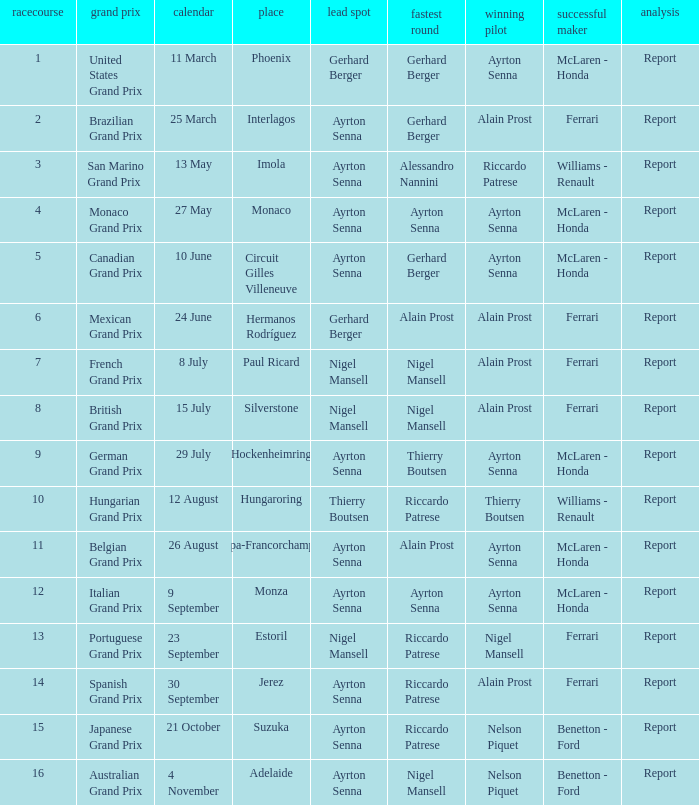Could you help me parse every detail presented in this table? {'header': ['racecourse', 'grand prix', 'calendar', 'place', 'lead spot', 'fastest round', 'winning pilot', 'successful maker', 'analysis'], 'rows': [['1', 'United States Grand Prix', '11 March', 'Phoenix', 'Gerhard Berger', 'Gerhard Berger', 'Ayrton Senna', 'McLaren - Honda', 'Report'], ['2', 'Brazilian Grand Prix', '25 March', 'Interlagos', 'Ayrton Senna', 'Gerhard Berger', 'Alain Prost', 'Ferrari', 'Report'], ['3', 'San Marino Grand Prix', '13 May', 'Imola', 'Ayrton Senna', 'Alessandro Nannini', 'Riccardo Patrese', 'Williams - Renault', 'Report'], ['4', 'Monaco Grand Prix', '27 May', 'Monaco', 'Ayrton Senna', 'Ayrton Senna', 'Ayrton Senna', 'McLaren - Honda', 'Report'], ['5', 'Canadian Grand Prix', '10 June', 'Circuit Gilles Villeneuve', 'Ayrton Senna', 'Gerhard Berger', 'Ayrton Senna', 'McLaren - Honda', 'Report'], ['6', 'Mexican Grand Prix', '24 June', 'Hermanos Rodríguez', 'Gerhard Berger', 'Alain Prost', 'Alain Prost', 'Ferrari', 'Report'], ['7', 'French Grand Prix', '8 July', 'Paul Ricard', 'Nigel Mansell', 'Nigel Mansell', 'Alain Prost', 'Ferrari', 'Report'], ['8', 'British Grand Prix', '15 July', 'Silverstone', 'Nigel Mansell', 'Nigel Mansell', 'Alain Prost', 'Ferrari', 'Report'], ['9', 'German Grand Prix', '29 July', 'Hockenheimring', 'Ayrton Senna', 'Thierry Boutsen', 'Ayrton Senna', 'McLaren - Honda', 'Report'], ['10', 'Hungarian Grand Prix', '12 August', 'Hungaroring', 'Thierry Boutsen', 'Riccardo Patrese', 'Thierry Boutsen', 'Williams - Renault', 'Report'], ['11', 'Belgian Grand Prix', '26 August', 'Spa-Francorchamps', 'Ayrton Senna', 'Alain Prost', 'Ayrton Senna', 'McLaren - Honda', 'Report'], ['12', 'Italian Grand Prix', '9 September', 'Monza', 'Ayrton Senna', 'Ayrton Senna', 'Ayrton Senna', 'McLaren - Honda', 'Report'], ['13', 'Portuguese Grand Prix', '23 September', 'Estoril', 'Nigel Mansell', 'Riccardo Patrese', 'Nigel Mansell', 'Ferrari', 'Report'], ['14', 'Spanish Grand Prix', '30 September', 'Jerez', 'Ayrton Senna', 'Riccardo Patrese', 'Alain Prost', 'Ferrari', 'Report'], ['15', 'Japanese Grand Prix', '21 October', 'Suzuka', 'Ayrton Senna', 'Riccardo Patrese', 'Nelson Piquet', 'Benetton - Ford', 'Report'], ['16', 'Australian Grand Prix', '4 November', 'Adelaide', 'Ayrton Senna', 'Nigel Mansell', 'Nelson Piquet', 'Benetton - Ford', 'Report']]} What is the Pole Position for the German Grand Prix Ayrton Senna. 